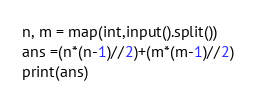Convert code to text. <code><loc_0><loc_0><loc_500><loc_500><_Python_>n, m = map(int,input().split())
ans =(n*(n-1)//2)+(m*(m-1)//2)
print(ans)</code> 